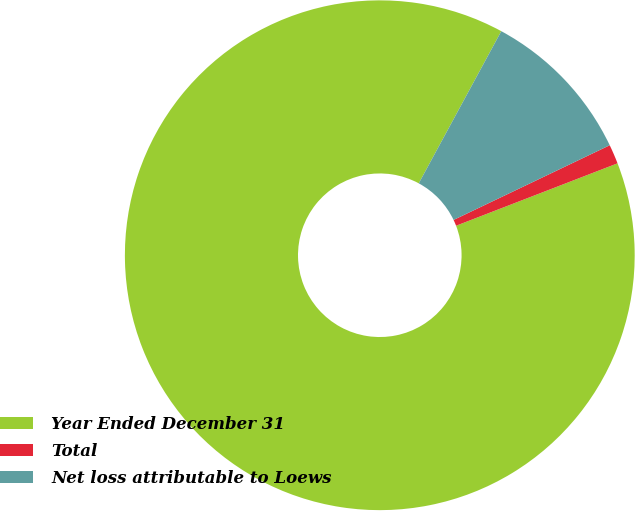<chart> <loc_0><loc_0><loc_500><loc_500><pie_chart><fcel>Year Ended December 31<fcel>Total<fcel>Net loss attributable to Loews<nl><fcel>88.78%<fcel>1.23%<fcel>9.99%<nl></chart> 